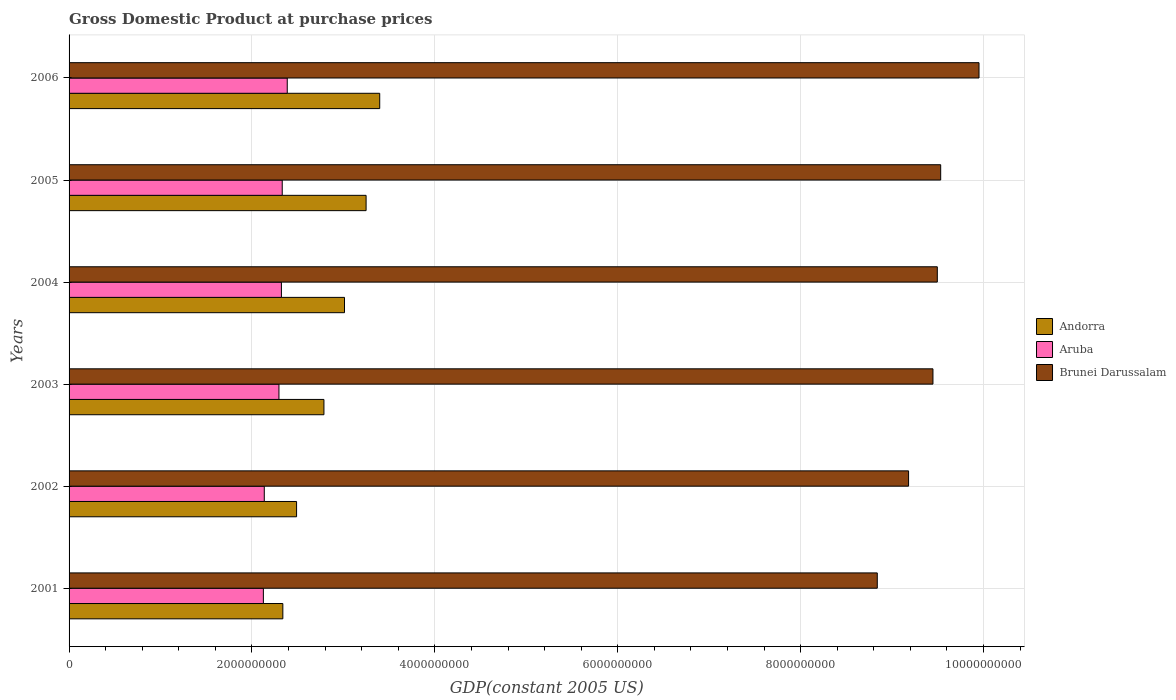How many different coloured bars are there?
Provide a succinct answer. 3. Are the number of bars on each tick of the Y-axis equal?
Offer a terse response. Yes. How many bars are there on the 2nd tick from the bottom?
Give a very brief answer. 3. In how many cases, is the number of bars for a given year not equal to the number of legend labels?
Provide a short and direct response. 0. What is the GDP at purchase prices in Andorra in 2001?
Your answer should be very brief. 2.34e+09. Across all years, what is the maximum GDP at purchase prices in Brunei Darussalam?
Provide a short and direct response. 9.95e+09. Across all years, what is the minimum GDP at purchase prices in Brunei Darussalam?
Give a very brief answer. 8.84e+09. In which year was the GDP at purchase prices in Aruba minimum?
Keep it short and to the point. 2001. What is the total GDP at purchase prices in Brunei Darussalam in the graph?
Your answer should be compact. 5.64e+1. What is the difference between the GDP at purchase prices in Brunei Darussalam in 2004 and that in 2005?
Your answer should be compact. -3.68e+07. What is the difference between the GDP at purchase prices in Andorra in 2003 and the GDP at purchase prices in Aruba in 2002?
Offer a terse response. 6.52e+08. What is the average GDP at purchase prices in Andorra per year?
Your answer should be compact. 2.88e+09. In the year 2005, what is the difference between the GDP at purchase prices in Brunei Darussalam and GDP at purchase prices in Aruba?
Provide a succinct answer. 7.20e+09. What is the ratio of the GDP at purchase prices in Brunei Darussalam in 2001 to that in 2002?
Keep it short and to the point. 0.96. Is the GDP at purchase prices in Andorra in 2004 less than that in 2005?
Provide a succinct answer. Yes. Is the difference between the GDP at purchase prices in Brunei Darussalam in 2004 and 2005 greater than the difference between the GDP at purchase prices in Aruba in 2004 and 2005?
Your answer should be very brief. No. What is the difference between the highest and the second highest GDP at purchase prices in Brunei Darussalam?
Your answer should be compact. 4.19e+08. What is the difference between the highest and the lowest GDP at purchase prices in Andorra?
Provide a succinct answer. 1.06e+09. Is the sum of the GDP at purchase prices in Andorra in 2003 and 2006 greater than the maximum GDP at purchase prices in Aruba across all years?
Keep it short and to the point. Yes. What does the 2nd bar from the top in 2001 represents?
Provide a short and direct response. Aruba. What does the 1st bar from the bottom in 2002 represents?
Make the answer very short. Andorra. Is it the case that in every year, the sum of the GDP at purchase prices in Andorra and GDP at purchase prices in Brunei Darussalam is greater than the GDP at purchase prices in Aruba?
Your answer should be compact. Yes. How many bars are there?
Offer a very short reply. 18. How many years are there in the graph?
Ensure brevity in your answer.  6. Are the values on the major ticks of X-axis written in scientific E-notation?
Your answer should be very brief. No. Does the graph contain any zero values?
Provide a succinct answer. No. Where does the legend appear in the graph?
Give a very brief answer. Center right. How many legend labels are there?
Ensure brevity in your answer.  3. How are the legend labels stacked?
Keep it short and to the point. Vertical. What is the title of the graph?
Offer a terse response. Gross Domestic Product at purchase prices. Does "Micronesia" appear as one of the legend labels in the graph?
Offer a very short reply. No. What is the label or title of the X-axis?
Offer a very short reply. GDP(constant 2005 US). What is the GDP(constant 2005 US) of Andorra in 2001?
Your response must be concise. 2.34e+09. What is the GDP(constant 2005 US) in Aruba in 2001?
Your response must be concise. 2.12e+09. What is the GDP(constant 2005 US) of Brunei Darussalam in 2001?
Ensure brevity in your answer.  8.84e+09. What is the GDP(constant 2005 US) in Andorra in 2002?
Give a very brief answer. 2.49e+09. What is the GDP(constant 2005 US) in Aruba in 2002?
Give a very brief answer. 2.13e+09. What is the GDP(constant 2005 US) of Brunei Darussalam in 2002?
Make the answer very short. 9.18e+09. What is the GDP(constant 2005 US) of Andorra in 2003?
Your answer should be very brief. 2.79e+09. What is the GDP(constant 2005 US) in Aruba in 2003?
Your answer should be very brief. 2.30e+09. What is the GDP(constant 2005 US) of Brunei Darussalam in 2003?
Offer a very short reply. 9.45e+09. What is the GDP(constant 2005 US) in Andorra in 2004?
Offer a terse response. 3.01e+09. What is the GDP(constant 2005 US) of Aruba in 2004?
Provide a succinct answer. 2.32e+09. What is the GDP(constant 2005 US) of Brunei Darussalam in 2004?
Offer a very short reply. 9.49e+09. What is the GDP(constant 2005 US) of Andorra in 2005?
Make the answer very short. 3.25e+09. What is the GDP(constant 2005 US) in Aruba in 2005?
Offer a terse response. 2.33e+09. What is the GDP(constant 2005 US) in Brunei Darussalam in 2005?
Keep it short and to the point. 9.53e+09. What is the GDP(constant 2005 US) in Andorra in 2006?
Your answer should be compact. 3.40e+09. What is the GDP(constant 2005 US) in Aruba in 2006?
Your answer should be compact. 2.39e+09. What is the GDP(constant 2005 US) of Brunei Darussalam in 2006?
Your answer should be very brief. 9.95e+09. Across all years, what is the maximum GDP(constant 2005 US) in Andorra?
Give a very brief answer. 3.40e+09. Across all years, what is the maximum GDP(constant 2005 US) of Aruba?
Ensure brevity in your answer.  2.39e+09. Across all years, what is the maximum GDP(constant 2005 US) of Brunei Darussalam?
Make the answer very short. 9.95e+09. Across all years, what is the minimum GDP(constant 2005 US) in Andorra?
Make the answer very short. 2.34e+09. Across all years, what is the minimum GDP(constant 2005 US) of Aruba?
Give a very brief answer. 2.12e+09. Across all years, what is the minimum GDP(constant 2005 US) in Brunei Darussalam?
Make the answer very short. 8.84e+09. What is the total GDP(constant 2005 US) in Andorra in the graph?
Provide a short and direct response. 1.73e+1. What is the total GDP(constant 2005 US) of Aruba in the graph?
Ensure brevity in your answer.  1.36e+1. What is the total GDP(constant 2005 US) of Brunei Darussalam in the graph?
Your response must be concise. 5.64e+1. What is the difference between the GDP(constant 2005 US) in Andorra in 2001 and that in 2002?
Your response must be concise. -1.50e+08. What is the difference between the GDP(constant 2005 US) of Aruba in 2001 and that in 2002?
Your response must be concise. -9.89e+06. What is the difference between the GDP(constant 2005 US) in Brunei Darussalam in 2001 and that in 2002?
Your answer should be very brief. -3.42e+08. What is the difference between the GDP(constant 2005 US) of Andorra in 2001 and that in 2003?
Offer a very short reply. -4.49e+08. What is the difference between the GDP(constant 2005 US) in Aruba in 2001 and that in 2003?
Your answer should be very brief. -1.70e+08. What is the difference between the GDP(constant 2005 US) of Brunei Darussalam in 2001 and that in 2003?
Your answer should be compact. -6.09e+08. What is the difference between the GDP(constant 2005 US) in Andorra in 2001 and that in 2004?
Your answer should be very brief. -6.74e+08. What is the difference between the GDP(constant 2005 US) of Aruba in 2001 and that in 2004?
Your answer should be compact. -1.97e+08. What is the difference between the GDP(constant 2005 US) in Brunei Darussalam in 2001 and that in 2004?
Offer a very short reply. -6.56e+08. What is the difference between the GDP(constant 2005 US) in Andorra in 2001 and that in 2005?
Offer a very short reply. -9.10e+08. What is the difference between the GDP(constant 2005 US) of Aruba in 2001 and that in 2005?
Your answer should be compact. -2.06e+08. What is the difference between the GDP(constant 2005 US) of Brunei Darussalam in 2001 and that in 2005?
Keep it short and to the point. -6.93e+08. What is the difference between the GDP(constant 2005 US) in Andorra in 2001 and that in 2006?
Provide a short and direct response. -1.06e+09. What is the difference between the GDP(constant 2005 US) of Aruba in 2001 and that in 2006?
Your answer should be compact. -2.61e+08. What is the difference between the GDP(constant 2005 US) of Brunei Darussalam in 2001 and that in 2006?
Keep it short and to the point. -1.11e+09. What is the difference between the GDP(constant 2005 US) of Andorra in 2002 and that in 2003?
Provide a short and direct response. -2.99e+08. What is the difference between the GDP(constant 2005 US) in Aruba in 2002 and that in 2003?
Your answer should be compact. -1.61e+08. What is the difference between the GDP(constant 2005 US) of Brunei Darussalam in 2002 and that in 2003?
Offer a terse response. -2.67e+08. What is the difference between the GDP(constant 2005 US) in Andorra in 2002 and that in 2004?
Provide a succinct answer. -5.24e+08. What is the difference between the GDP(constant 2005 US) in Aruba in 2002 and that in 2004?
Offer a very short reply. -1.88e+08. What is the difference between the GDP(constant 2005 US) of Brunei Darussalam in 2002 and that in 2004?
Offer a terse response. -3.14e+08. What is the difference between the GDP(constant 2005 US) of Andorra in 2002 and that in 2005?
Give a very brief answer. -7.60e+08. What is the difference between the GDP(constant 2005 US) of Aruba in 2002 and that in 2005?
Your answer should be very brief. -1.96e+08. What is the difference between the GDP(constant 2005 US) in Brunei Darussalam in 2002 and that in 2005?
Your answer should be compact. -3.51e+08. What is the difference between the GDP(constant 2005 US) of Andorra in 2002 and that in 2006?
Provide a succinct answer. -9.09e+08. What is the difference between the GDP(constant 2005 US) in Aruba in 2002 and that in 2006?
Give a very brief answer. -2.51e+08. What is the difference between the GDP(constant 2005 US) in Brunei Darussalam in 2002 and that in 2006?
Ensure brevity in your answer.  -7.70e+08. What is the difference between the GDP(constant 2005 US) in Andorra in 2003 and that in 2004?
Your answer should be compact. -2.25e+08. What is the difference between the GDP(constant 2005 US) in Aruba in 2003 and that in 2004?
Offer a very short reply. -2.70e+07. What is the difference between the GDP(constant 2005 US) in Brunei Darussalam in 2003 and that in 2004?
Make the answer very short. -4.76e+07. What is the difference between the GDP(constant 2005 US) of Andorra in 2003 and that in 2005?
Offer a terse response. -4.61e+08. What is the difference between the GDP(constant 2005 US) of Aruba in 2003 and that in 2005?
Provide a succinct answer. -3.58e+07. What is the difference between the GDP(constant 2005 US) of Brunei Darussalam in 2003 and that in 2005?
Make the answer very short. -8.44e+07. What is the difference between the GDP(constant 2005 US) of Andorra in 2003 and that in 2006?
Offer a very short reply. -6.10e+08. What is the difference between the GDP(constant 2005 US) in Aruba in 2003 and that in 2006?
Provide a short and direct response. -9.07e+07. What is the difference between the GDP(constant 2005 US) of Brunei Darussalam in 2003 and that in 2006?
Give a very brief answer. -5.04e+08. What is the difference between the GDP(constant 2005 US) of Andorra in 2004 and that in 2005?
Offer a very short reply. -2.36e+08. What is the difference between the GDP(constant 2005 US) of Aruba in 2004 and that in 2005?
Your answer should be very brief. -8.83e+06. What is the difference between the GDP(constant 2005 US) in Brunei Darussalam in 2004 and that in 2005?
Offer a very short reply. -3.68e+07. What is the difference between the GDP(constant 2005 US) in Andorra in 2004 and that in 2006?
Keep it short and to the point. -3.85e+08. What is the difference between the GDP(constant 2005 US) in Aruba in 2004 and that in 2006?
Provide a short and direct response. -6.37e+07. What is the difference between the GDP(constant 2005 US) in Brunei Darussalam in 2004 and that in 2006?
Ensure brevity in your answer.  -4.56e+08. What is the difference between the GDP(constant 2005 US) in Andorra in 2005 and that in 2006?
Offer a terse response. -1.49e+08. What is the difference between the GDP(constant 2005 US) in Aruba in 2005 and that in 2006?
Keep it short and to the point. -5.49e+07. What is the difference between the GDP(constant 2005 US) in Brunei Darussalam in 2005 and that in 2006?
Keep it short and to the point. -4.19e+08. What is the difference between the GDP(constant 2005 US) of Andorra in 2001 and the GDP(constant 2005 US) of Aruba in 2002?
Your response must be concise. 2.03e+08. What is the difference between the GDP(constant 2005 US) in Andorra in 2001 and the GDP(constant 2005 US) in Brunei Darussalam in 2002?
Your response must be concise. -6.84e+09. What is the difference between the GDP(constant 2005 US) in Aruba in 2001 and the GDP(constant 2005 US) in Brunei Darussalam in 2002?
Make the answer very short. -7.06e+09. What is the difference between the GDP(constant 2005 US) in Andorra in 2001 and the GDP(constant 2005 US) in Aruba in 2003?
Make the answer very short. 4.25e+07. What is the difference between the GDP(constant 2005 US) in Andorra in 2001 and the GDP(constant 2005 US) in Brunei Darussalam in 2003?
Your response must be concise. -7.11e+09. What is the difference between the GDP(constant 2005 US) in Aruba in 2001 and the GDP(constant 2005 US) in Brunei Darussalam in 2003?
Your response must be concise. -7.32e+09. What is the difference between the GDP(constant 2005 US) of Andorra in 2001 and the GDP(constant 2005 US) of Aruba in 2004?
Provide a succinct answer. 1.55e+07. What is the difference between the GDP(constant 2005 US) of Andorra in 2001 and the GDP(constant 2005 US) of Brunei Darussalam in 2004?
Your answer should be compact. -7.16e+09. What is the difference between the GDP(constant 2005 US) in Aruba in 2001 and the GDP(constant 2005 US) in Brunei Darussalam in 2004?
Your answer should be very brief. -7.37e+09. What is the difference between the GDP(constant 2005 US) of Andorra in 2001 and the GDP(constant 2005 US) of Aruba in 2005?
Your response must be concise. 6.70e+06. What is the difference between the GDP(constant 2005 US) in Andorra in 2001 and the GDP(constant 2005 US) in Brunei Darussalam in 2005?
Give a very brief answer. -7.19e+09. What is the difference between the GDP(constant 2005 US) in Aruba in 2001 and the GDP(constant 2005 US) in Brunei Darussalam in 2005?
Make the answer very short. -7.41e+09. What is the difference between the GDP(constant 2005 US) of Andorra in 2001 and the GDP(constant 2005 US) of Aruba in 2006?
Your answer should be compact. -4.82e+07. What is the difference between the GDP(constant 2005 US) of Andorra in 2001 and the GDP(constant 2005 US) of Brunei Darussalam in 2006?
Offer a terse response. -7.61e+09. What is the difference between the GDP(constant 2005 US) of Aruba in 2001 and the GDP(constant 2005 US) of Brunei Darussalam in 2006?
Your answer should be compact. -7.83e+09. What is the difference between the GDP(constant 2005 US) of Andorra in 2002 and the GDP(constant 2005 US) of Aruba in 2003?
Your response must be concise. 1.93e+08. What is the difference between the GDP(constant 2005 US) of Andorra in 2002 and the GDP(constant 2005 US) of Brunei Darussalam in 2003?
Offer a very short reply. -6.96e+09. What is the difference between the GDP(constant 2005 US) of Aruba in 2002 and the GDP(constant 2005 US) of Brunei Darussalam in 2003?
Make the answer very short. -7.31e+09. What is the difference between the GDP(constant 2005 US) of Andorra in 2002 and the GDP(constant 2005 US) of Aruba in 2004?
Offer a very short reply. 1.66e+08. What is the difference between the GDP(constant 2005 US) of Andorra in 2002 and the GDP(constant 2005 US) of Brunei Darussalam in 2004?
Ensure brevity in your answer.  -7.01e+09. What is the difference between the GDP(constant 2005 US) of Aruba in 2002 and the GDP(constant 2005 US) of Brunei Darussalam in 2004?
Your answer should be very brief. -7.36e+09. What is the difference between the GDP(constant 2005 US) in Andorra in 2002 and the GDP(constant 2005 US) in Aruba in 2005?
Your response must be concise. 1.57e+08. What is the difference between the GDP(constant 2005 US) in Andorra in 2002 and the GDP(constant 2005 US) in Brunei Darussalam in 2005?
Offer a terse response. -7.04e+09. What is the difference between the GDP(constant 2005 US) in Aruba in 2002 and the GDP(constant 2005 US) in Brunei Darussalam in 2005?
Give a very brief answer. -7.40e+09. What is the difference between the GDP(constant 2005 US) of Andorra in 2002 and the GDP(constant 2005 US) of Aruba in 2006?
Make the answer very short. 1.02e+08. What is the difference between the GDP(constant 2005 US) in Andorra in 2002 and the GDP(constant 2005 US) in Brunei Darussalam in 2006?
Your answer should be compact. -7.46e+09. What is the difference between the GDP(constant 2005 US) of Aruba in 2002 and the GDP(constant 2005 US) of Brunei Darussalam in 2006?
Offer a very short reply. -7.82e+09. What is the difference between the GDP(constant 2005 US) in Andorra in 2003 and the GDP(constant 2005 US) in Aruba in 2004?
Your response must be concise. 4.65e+08. What is the difference between the GDP(constant 2005 US) in Andorra in 2003 and the GDP(constant 2005 US) in Brunei Darussalam in 2004?
Your answer should be compact. -6.71e+09. What is the difference between the GDP(constant 2005 US) of Aruba in 2003 and the GDP(constant 2005 US) of Brunei Darussalam in 2004?
Provide a succinct answer. -7.20e+09. What is the difference between the GDP(constant 2005 US) in Andorra in 2003 and the GDP(constant 2005 US) in Aruba in 2005?
Keep it short and to the point. 4.56e+08. What is the difference between the GDP(constant 2005 US) in Andorra in 2003 and the GDP(constant 2005 US) in Brunei Darussalam in 2005?
Your answer should be compact. -6.74e+09. What is the difference between the GDP(constant 2005 US) in Aruba in 2003 and the GDP(constant 2005 US) in Brunei Darussalam in 2005?
Make the answer very short. -7.24e+09. What is the difference between the GDP(constant 2005 US) in Andorra in 2003 and the GDP(constant 2005 US) in Aruba in 2006?
Your answer should be compact. 4.01e+08. What is the difference between the GDP(constant 2005 US) of Andorra in 2003 and the GDP(constant 2005 US) of Brunei Darussalam in 2006?
Provide a short and direct response. -7.16e+09. What is the difference between the GDP(constant 2005 US) in Aruba in 2003 and the GDP(constant 2005 US) in Brunei Darussalam in 2006?
Give a very brief answer. -7.66e+09. What is the difference between the GDP(constant 2005 US) of Andorra in 2004 and the GDP(constant 2005 US) of Aruba in 2005?
Provide a succinct answer. 6.81e+08. What is the difference between the GDP(constant 2005 US) in Andorra in 2004 and the GDP(constant 2005 US) in Brunei Darussalam in 2005?
Ensure brevity in your answer.  -6.52e+09. What is the difference between the GDP(constant 2005 US) in Aruba in 2004 and the GDP(constant 2005 US) in Brunei Darussalam in 2005?
Your answer should be very brief. -7.21e+09. What is the difference between the GDP(constant 2005 US) of Andorra in 2004 and the GDP(constant 2005 US) of Aruba in 2006?
Give a very brief answer. 6.26e+08. What is the difference between the GDP(constant 2005 US) in Andorra in 2004 and the GDP(constant 2005 US) in Brunei Darussalam in 2006?
Keep it short and to the point. -6.94e+09. What is the difference between the GDP(constant 2005 US) in Aruba in 2004 and the GDP(constant 2005 US) in Brunei Darussalam in 2006?
Your response must be concise. -7.63e+09. What is the difference between the GDP(constant 2005 US) in Andorra in 2005 and the GDP(constant 2005 US) in Aruba in 2006?
Your response must be concise. 8.62e+08. What is the difference between the GDP(constant 2005 US) in Andorra in 2005 and the GDP(constant 2005 US) in Brunei Darussalam in 2006?
Your response must be concise. -6.70e+09. What is the difference between the GDP(constant 2005 US) of Aruba in 2005 and the GDP(constant 2005 US) of Brunei Darussalam in 2006?
Keep it short and to the point. -7.62e+09. What is the average GDP(constant 2005 US) in Andorra per year?
Make the answer very short. 2.88e+09. What is the average GDP(constant 2005 US) of Aruba per year?
Provide a short and direct response. 2.27e+09. What is the average GDP(constant 2005 US) in Brunei Darussalam per year?
Your answer should be compact. 9.41e+09. In the year 2001, what is the difference between the GDP(constant 2005 US) in Andorra and GDP(constant 2005 US) in Aruba?
Make the answer very short. 2.13e+08. In the year 2001, what is the difference between the GDP(constant 2005 US) of Andorra and GDP(constant 2005 US) of Brunei Darussalam?
Your response must be concise. -6.50e+09. In the year 2001, what is the difference between the GDP(constant 2005 US) of Aruba and GDP(constant 2005 US) of Brunei Darussalam?
Your answer should be compact. -6.71e+09. In the year 2002, what is the difference between the GDP(constant 2005 US) in Andorra and GDP(constant 2005 US) in Aruba?
Provide a succinct answer. 3.53e+08. In the year 2002, what is the difference between the GDP(constant 2005 US) in Andorra and GDP(constant 2005 US) in Brunei Darussalam?
Provide a succinct answer. -6.69e+09. In the year 2002, what is the difference between the GDP(constant 2005 US) in Aruba and GDP(constant 2005 US) in Brunei Darussalam?
Provide a short and direct response. -7.05e+09. In the year 2003, what is the difference between the GDP(constant 2005 US) in Andorra and GDP(constant 2005 US) in Aruba?
Your answer should be very brief. 4.92e+08. In the year 2003, what is the difference between the GDP(constant 2005 US) in Andorra and GDP(constant 2005 US) in Brunei Darussalam?
Ensure brevity in your answer.  -6.66e+09. In the year 2003, what is the difference between the GDP(constant 2005 US) in Aruba and GDP(constant 2005 US) in Brunei Darussalam?
Make the answer very short. -7.15e+09. In the year 2004, what is the difference between the GDP(constant 2005 US) in Andorra and GDP(constant 2005 US) in Aruba?
Provide a succinct answer. 6.90e+08. In the year 2004, what is the difference between the GDP(constant 2005 US) of Andorra and GDP(constant 2005 US) of Brunei Darussalam?
Offer a very short reply. -6.48e+09. In the year 2004, what is the difference between the GDP(constant 2005 US) in Aruba and GDP(constant 2005 US) in Brunei Darussalam?
Your answer should be very brief. -7.17e+09. In the year 2005, what is the difference between the GDP(constant 2005 US) in Andorra and GDP(constant 2005 US) in Aruba?
Your answer should be very brief. 9.17e+08. In the year 2005, what is the difference between the GDP(constant 2005 US) in Andorra and GDP(constant 2005 US) in Brunei Darussalam?
Make the answer very short. -6.28e+09. In the year 2005, what is the difference between the GDP(constant 2005 US) in Aruba and GDP(constant 2005 US) in Brunei Darussalam?
Provide a short and direct response. -7.20e+09. In the year 2006, what is the difference between the GDP(constant 2005 US) in Andorra and GDP(constant 2005 US) in Aruba?
Keep it short and to the point. 1.01e+09. In the year 2006, what is the difference between the GDP(constant 2005 US) in Andorra and GDP(constant 2005 US) in Brunei Darussalam?
Offer a very short reply. -6.55e+09. In the year 2006, what is the difference between the GDP(constant 2005 US) of Aruba and GDP(constant 2005 US) of Brunei Darussalam?
Your answer should be compact. -7.56e+09. What is the ratio of the GDP(constant 2005 US) of Andorra in 2001 to that in 2002?
Your answer should be very brief. 0.94. What is the ratio of the GDP(constant 2005 US) in Brunei Darussalam in 2001 to that in 2002?
Provide a short and direct response. 0.96. What is the ratio of the GDP(constant 2005 US) of Andorra in 2001 to that in 2003?
Your answer should be compact. 0.84. What is the ratio of the GDP(constant 2005 US) in Aruba in 2001 to that in 2003?
Your answer should be very brief. 0.93. What is the ratio of the GDP(constant 2005 US) of Brunei Darussalam in 2001 to that in 2003?
Your answer should be compact. 0.94. What is the ratio of the GDP(constant 2005 US) of Andorra in 2001 to that in 2004?
Ensure brevity in your answer.  0.78. What is the ratio of the GDP(constant 2005 US) of Aruba in 2001 to that in 2004?
Offer a very short reply. 0.92. What is the ratio of the GDP(constant 2005 US) in Brunei Darussalam in 2001 to that in 2004?
Offer a terse response. 0.93. What is the ratio of the GDP(constant 2005 US) in Andorra in 2001 to that in 2005?
Provide a succinct answer. 0.72. What is the ratio of the GDP(constant 2005 US) in Aruba in 2001 to that in 2005?
Ensure brevity in your answer.  0.91. What is the ratio of the GDP(constant 2005 US) of Brunei Darussalam in 2001 to that in 2005?
Your answer should be compact. 0.93. What is the ratio of the GDP(constant 2005 US) of Andorra in 2001 to that in 2006?
Your answer should be very brief. 0.69. What is the ratio of the GDP(constant 2005 US) of Aruba in 2001 to that in 2006?
Keep it short and to the point. 0.89. What is the ratio of the GDP(constant 2005 US) in Brunei Darussalam in 2001 to that in 2006?
Your response must be concise. 0.89. What is the ratio of the GDP(constant 2005 US) of Andorra in 2002 to that in 2003?
Make the answer very short. 0.89. What is the ratio of the GDP(constant 2005 US) of Aruba in 2002 to that in 2003?
Your answer should be very brief. 0.93. What is the ratio of the GDP(constant 2005 US) of Brunei Darussalam in 2002 to that in 2003?
Offer a very short reply. 0.97. What is the ratio of the GDP(constant 2005 US) of Andorra in 2002 to that in 2004?
Your answer should be compact. 0.83. What is the ratio of the GDP(constant 2005 US) in Aruba in 2002 to that in 2004?
Your response must be concise. 0.92. What is the ratio of the GDP(constant 2005 US) in Brunei Darussalam in 2002 to that in 2004?
Offer a very short reply. 0.97. What is the ratio of the GDP(constant 2005 US) in Andorra in 2002 to that in 2005?
Make the answer very short. 0.77. What is the ratio of the GDP(constant 2005 US) of Aruba in 2002 to that in 2005?
Ensure brevity in your answer.  0.92. What is the ratio of the GDP(constant 2005 US) in Brunei Darussalam in 2002 to that in 2005?
Your answer should be compact. 0.96. What is the ratio of the GDP(constant 2005 US) in Andorra in 2002 to that in 2006?
Your answer should be compact. 0.73. What is the ratio of the GDP(constant 2005 US) in Aruba in 2002 to that in 2006?
Offer a terse response. 0.89. What is the ratio of the GDP(constant 2005 US) in Brunei Darussalam in 2002 to that in 2006?
Give a very brief answer. 0.92. What is the ratio of the GDP(constant 2005 US) of Andorra in 2003 to that in 2004?
Make the answer very short. 0.93. What is the ratio of the GDP(constant 2005 US) of Aruba in 2003 to that in 2004?
Offer a terse response. 0.99. What is the ratio of the GDP(constant 2005 US) of Brunei Darussalam in 2003 to that in 2004?
Provide a short and direct response. 0.99. What is the ratio of the GDP(constant 2005 US) in Andorra in 2003 to that in 2005?
Ensure brevity in your answer.  0.86. What is the ratio of the GDP(constant 2005 US) in Aruba in 2003 to that in 2005?
Your response must be concise. 0.98. What is the ratio of the GDP(constant 2005 US) in Brunei Darussalam in 2003 to that in 2005?
Provide a short and direct response. 0.99. What is the ratio of the GDP(constant 2005 US) of Andorra in 2003 to that in 2006?
Provide a succinct answer. 0.82. What is the ratio of the GDP(constant 2005 US) in Aruba in 2003 to that in 2006?
Ensure brevity in your answer.  0.96. What is the ratio of the GDP(constant 2005 US) in Brunei Darussalam in 2003 to that in 2006?
Provide a succinct answer. 0.95. What is the ratio of the GDP(constant 2005 US) of Andorra in 2004 to that in 2005?
Your response must be concise. 0.93. What is the ratio of the GDP(constant 2005 US) in Andorra in 2004 to that in 2006?
Offer a very short reply. 0.89. What is the ratio of the GDP(constant 2005 US) of Aruba in 2004 to that in 2006?
Offer a terse response. 0.97. What is the ratio of the GDP(constant 2005 US) of Brunei Darussalam in 2004 to that in 2006?
Give a very brief answer. 0.95. What is the ratio of the GDP(constant 2005 US) in Andorra in 2005 to that in 2006?
Your answer should be very brief. 0.96. What is the ratio of the GDP(constant 2005 US) in Aruba in 2005 to that in 2006?
Your response must be concise. 0.98. What is the ratio of the GDP(constant 2005 US) of Brunei Darussalam in 2005 to that in 2006?
Your response must be concise. 0.96. What is the difference between the highest and the second highest GDP(constant 2005 US) in Andorra?
Your answer should be compact. 1.49e+08. What is the difference between the highest and the second highest GDP(constant 2005 US) of Aruba?
Your answer should be very brief. 5.49e+07. What is the difference between the highest and the second highest GDP(constant 2005 US) of Brunei Darussalam?
Make the answer very short. 4.19e+08. What is the difference between the highest and the lowest GDP(constant 2005 US) of Andorra?
Provide a succinct answer. 1.06e+09. What is the difference between the highest and the lowest GDP(constant 2005 US) in Aruba?
Give a very brief answer. 2.61e+08. What is the difference between the highest and the lowest GDP(constant 2005 US) of Brunei Darussalam?
Make the answer very short. 1.11e+09. 